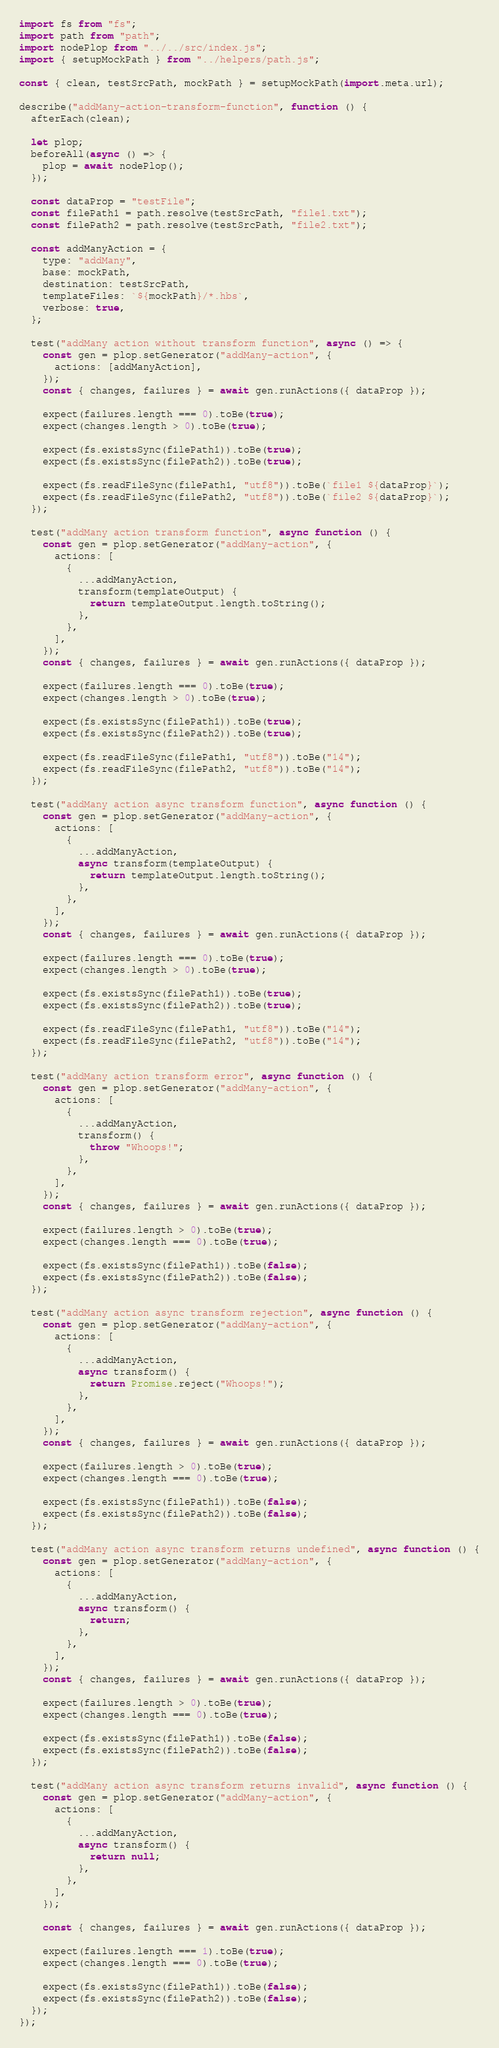Convert code to text. <code><loc_0><loc_0><loc_500><loc_500><_JavaScript_>import fs from "fs";
import path from "path";
import nodePlop from "../../src/index.js";
import { setupMockPath } from "../helpers/path.js";

const { clean, testSrcPath, mockPath } = setupMockPath(import.meta.url);

describe("addMany-action-transform-function", function () {
  afterEach(clean);

  let plop;
  beforeAll(async () => {
    plop = await nodePlop();
  });

  const dataProp = "testFile";
  const filePath1 = path.resolve(testSrcPath, "file1.txt");
  const filePath2 = path.resolve(testSrcPath, "file2.txt");

  const addManyAction = {
    type: "addMany",
    base: mockPath,
    destination: testSrcPath,
    templateFiles: `${mockPath}/*.hbs`,
    verbose: true,
  };

  test("addMany action without transform function", async () => {
    const gen = plop.setGenerator("addMany-action", {
      actions: [addManyAction],
    });
    const { changes, failures } = await gen.runActions({ dataProp });

    expect(failures.length === 0).toBe(true);
    expect(changes.length > 0).toBe(true);

    expect(fs.existsSync(filePath1)).toBe(true);
    expect(fs.existsSync(filePath2)).toBe(true);

    expect(fs.readFileSync(filePath1, "utf8")).toBe(`file1 ${dataProp}`);
    expect(fs.readFileSync(filePath2, "utf8")).toBe(`file2 ${dataProp}`);
  });

  test("addMany action transform function", async function () {
    const gen = plop.setGenerator("addMany-action", {
      actions: [
        {
          ...addManyAction,
          transform(templateOutput) {
            return templateOutput.length.toString();
          },
        },
      ],
    });
    const { changes, failures } = await gen.runActions({ dataProp });

    expect(failures.length === 0).toBe(true);
    expect(changes.length > 0).toBe(true);

    expect(fs.existsSync(filePath1)).toBe(true);
    expect(fs.existsSync(filePath2)).toBe(true);

    expect(fs.readFileSync(filePath1, "utf8")).toBe("14");
    expect(fs.readFileSync(filePath2, "utf8")).toBe("14");
  });

  test("addMany action async transform function", async function () {
    const gen = plop.setGenerator("addMany-action", {
      actions: [
        {
          ...addManyAction,
          async transform(templateOutput) {
            return templateOutput.length.toString();
          },
        },
      ],
    });
    const { changes, failures } = await gen.runActions({ dataProp });

    expect(failures.length === 0).toBe(true);
    expect(changes.length > 0).toBe(true);

    expect(fs.existsSync(filePath1)).toBe(true);
    expect(fs.existsSync(filePath2)).toBe(true);

    expect(fs.readFileSync(filePath1, "utf8")).toBe("14");
    expect(fs.readFileSync(filePath2, "utf8")).toBe("14");
  });

  test("addMany action transform error", async function () {
    const gen = plop.setGenerator("addMany-action", {
      actions: [
        {
          ...addManyAction,
          transform() {
            throw "Whoops!";
          },
        },
      ],
    });
    const { changes, failures } = await gen.runActions({ dataProp });

    expect(failures.length > 0).toBe(true);
    expect(changes.length === 0).toBe(true);

    expect(fs.existsSync(filePath1)).toBe(false);
    expect(fs.existsSync(filePath2)).toBe(false);
  });

  test("addMany action async transform rejection", async function () {
    const gen = plop.setGenerator("addMany-action", {
      actions: [
        {
          ...addManyAction,
          async transform() {
            return Promise.reject("Whoops!");
          },
        },
      ],
    });
    const { changes, failures } = await gen.runActions({ dataProp });

    expect(failures.length > 0).toBe(true);
    expect(changes.length === 0).toBe(true);

    expect(fs.existsSync(filePath1)).toBe(false);
    expect(fs.existsSync(filePath2)).toBe(false);
  });

  test("addMany action async transform returns undefined", async function () {
    const gen = plop.setGenerator("addMany-action", {
      actions: [
        {
          ...addManyAction,
          async transform() {
            return;
          },
        },
      ],
    });
    const { changes, failures } = await gen.runActions({ dataProp });

    expect(failures.length > 0).toBe(true);
    expect(changes.length === 0).toBe(true);

    expect(fs.existsSync(filePath1)).toBe(false);
    expect(fs.existsSync(filePath2)).toBe(false);
  });

  test("addMany action async transform returns invalid", async function () {
    const gen = plop.setGenerator("addMany-action", {
      actions: [
        {
          ...addManyAction,
          async transform() {
            return null;
          },
        },
      ],
    });

    const { changes, failures } = await gen.runActions({ dataProp });

    expect(failures.length === 1).toBe(true);
    expect(changes.length === 0).toBe(true);

    expect(fs.existsSync(filePath1)).toBe(false);
    expect(fs.existsSync(filePath2)).toBe(false);
  });
});
</code> 